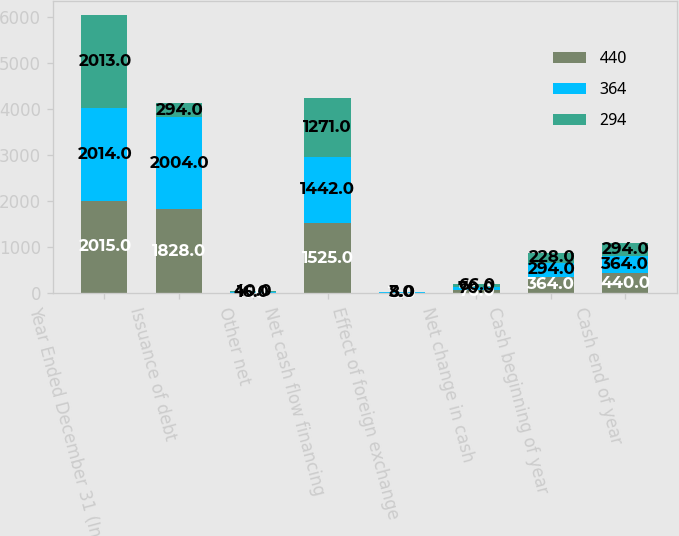Convert chart. <chart><loc_0><loc_0><loc_500><loc_500><stacked_bar_chart><ecel><fcel>Year Ended December 31 (In<fcel>Issuance of debt<fcel>Other net<fcel>Net cash flow financing<fcel>Effect of foreign exchange<fcel>Net change in cash<fcel>Cash beginning of year<fcel>Cash end of year<nl><fcel>440<fcel>2015<fcel>1828<fcel>4<fcel>1525<fcel>11<fcel>76<fcel>364<fcel>440<nl><fcel>364<fcel>2014<fcel>2004<fcel>16<fcel>1442<fcel>8<fcel>70<fcel>294<fcel>364<nl><fcel>294<fcel>2013<fcel>294<fcel>40<fcel>1271<fcel>3<fcel>66<fcel>228<fcel>294<nl></chart> 